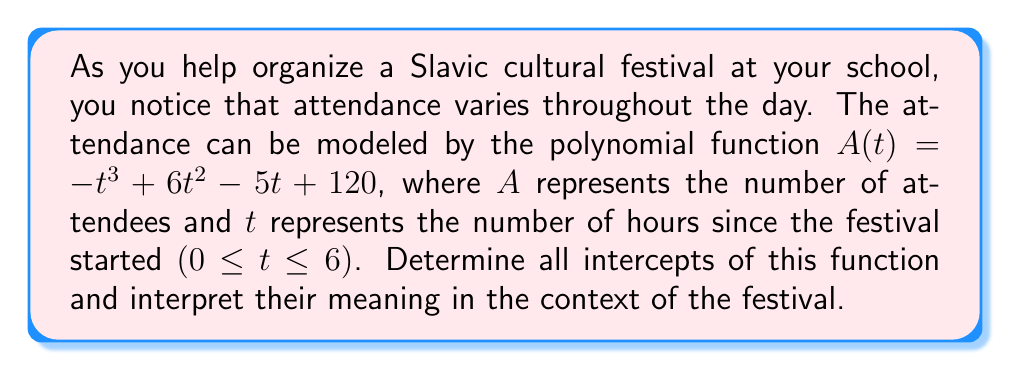Solve this math problem. To find the intercepts, we need to determine where the function crosses the x-axis (t-intercepts) and y-axis (A-intercept).

1. A-intercept (y-intercept):
   This occurs when t = 0.
   $A(0) = -(0)^3 + 6(0)^2 - 5(0) + 120 = 120$
   The A-intercept is (0, 120).

2. t-intercepts (x-intercepts):
   We need to solve the equation $A(t) = 0$:
   $-t^3 + 6t^2 - 5t + 120 = 0$

   This is a cubic equation. We can factor out the greatest common factor:
   $-1(t^3 - 6t^2 + 5t - 120) = 0$

   By inspection or using the rational root theorem, we can find that t = 5 is a solution.
   Factoring this out:
   $-(t - 5)(t^2 - t + 24) = 0$

   Using the quadratic formula on $t^2 - t + 24 = 0$:
   $t = \frac{1 \pm \sqrt{1^2 - 4(1)(24)}}{2(1)} = \frac{1 \pm \sqrt{-95}}{2}$

   Since this results in complex roots, the only real t-intercept is t = 5.

Interpretation:
- The A-intercept (0, 120) means that when the festival starts (t = 0), there are 120 attendees.
- The t-intercept (5, 0) indicates that after 5 hours, the attendance drops to 0, suggesting the festival effectively ends at this time.
Answer: A-intercept: (0, 120)
t-intercept: (5, 0) 